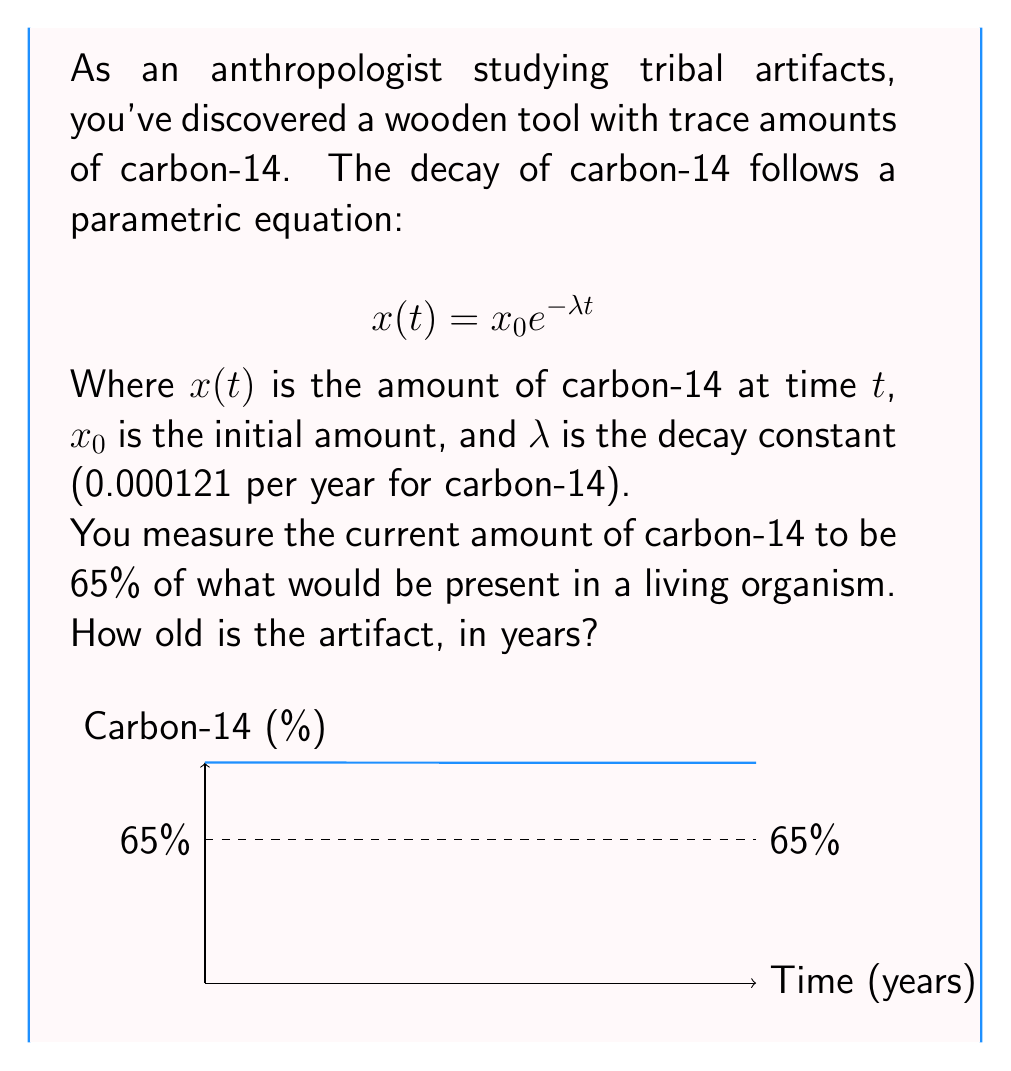Can you solve this math problem? Let's approach this step-by-step:

1) We start with the parametric decay equation:
   $$x(t) = x_0 e^{-\lambda t}$$

2) We know that the current amount is 65% of the original. This means:
   $$\frac{x(t)}{x_0} = 0.65$$

3) Substituting this into our equation:
   $$0.65 = e^{-\lambda t}$$

4) Taking the natural log of both sides:
   $$\ln(0.65) = -\lambda t$$

5) Solving for $t$:
   $$t = -\frac{\ln(0.65)}{\lambda}$$

6) We know $\lambda = 0.000121$ per year for carbon-14. Let's substitute this:
   $$t = -\frac{\ln(0.65)}{0.000121}$$

7) Now we can calculate:
   $$t = -\frac{-0.4308}{0.000121} \approx 3560$$

Therefore, the artifact is approximately 3560 years old.
Answer: 3560 years 